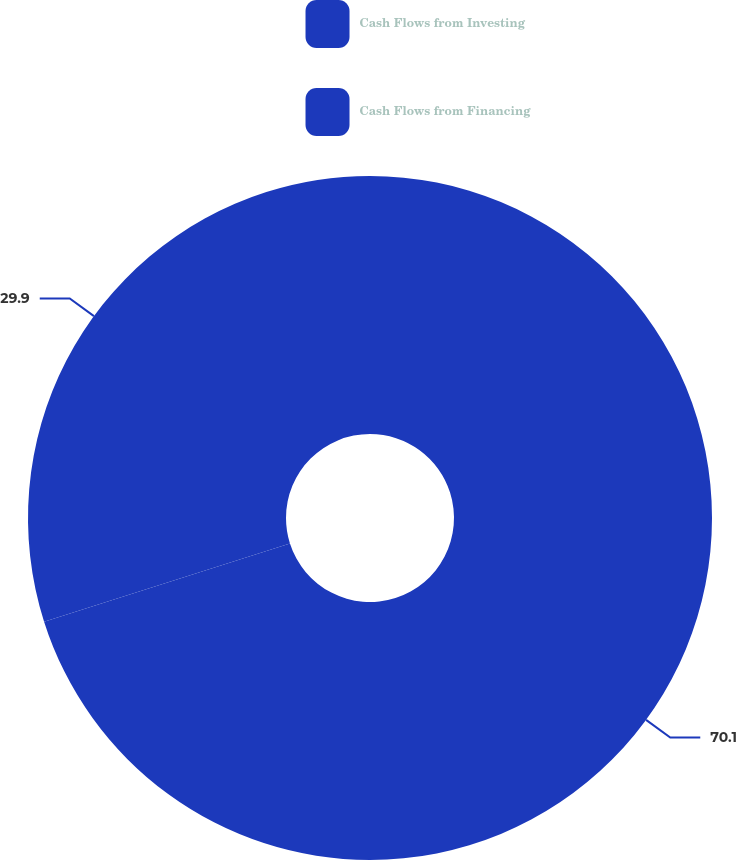Convert chart. <chart><loc_0><loc_0><loc_500><loc_500><pie_chart><fcel>Cash Flows from Investing<fcel>Cash Flows from Financing<nl><fcel>70.1%<fcel>29.9%<nl></chart> 